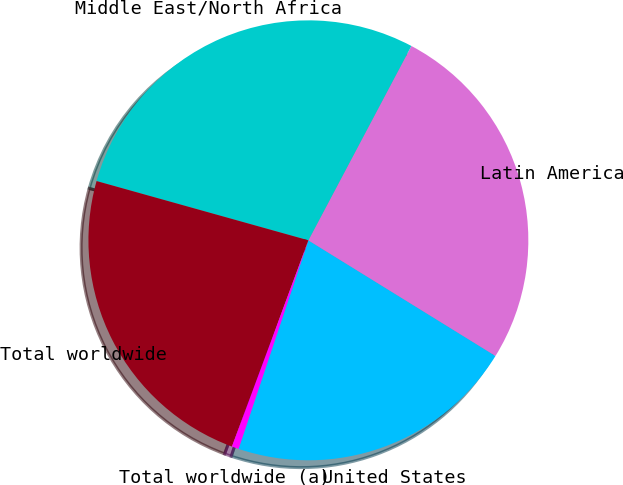Convert chart to OTSL. <chart><loc_0><loc_0><loc_500><loc_500><pie_chart><fcel>United States<fcel>Latin America<fcel>Middle East/North Africa<fcel>Total worldwide<fcel>Total worldwide (a)<nl><fcel>21.33%<fcel>26.05%<fcel>28.41%<fcel>23.69%<fcel>0.51%<nl></chart> 